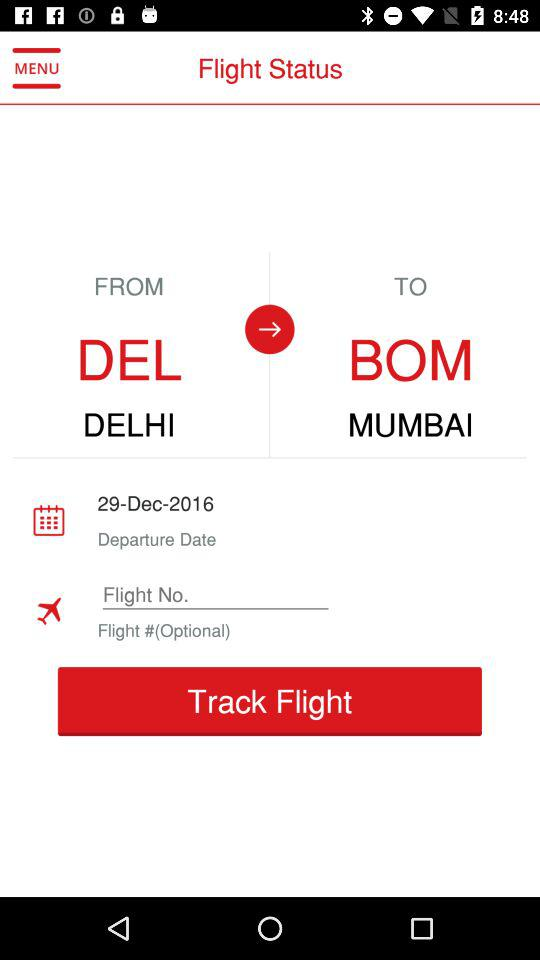What is the destination? The destination is Mumbai. 